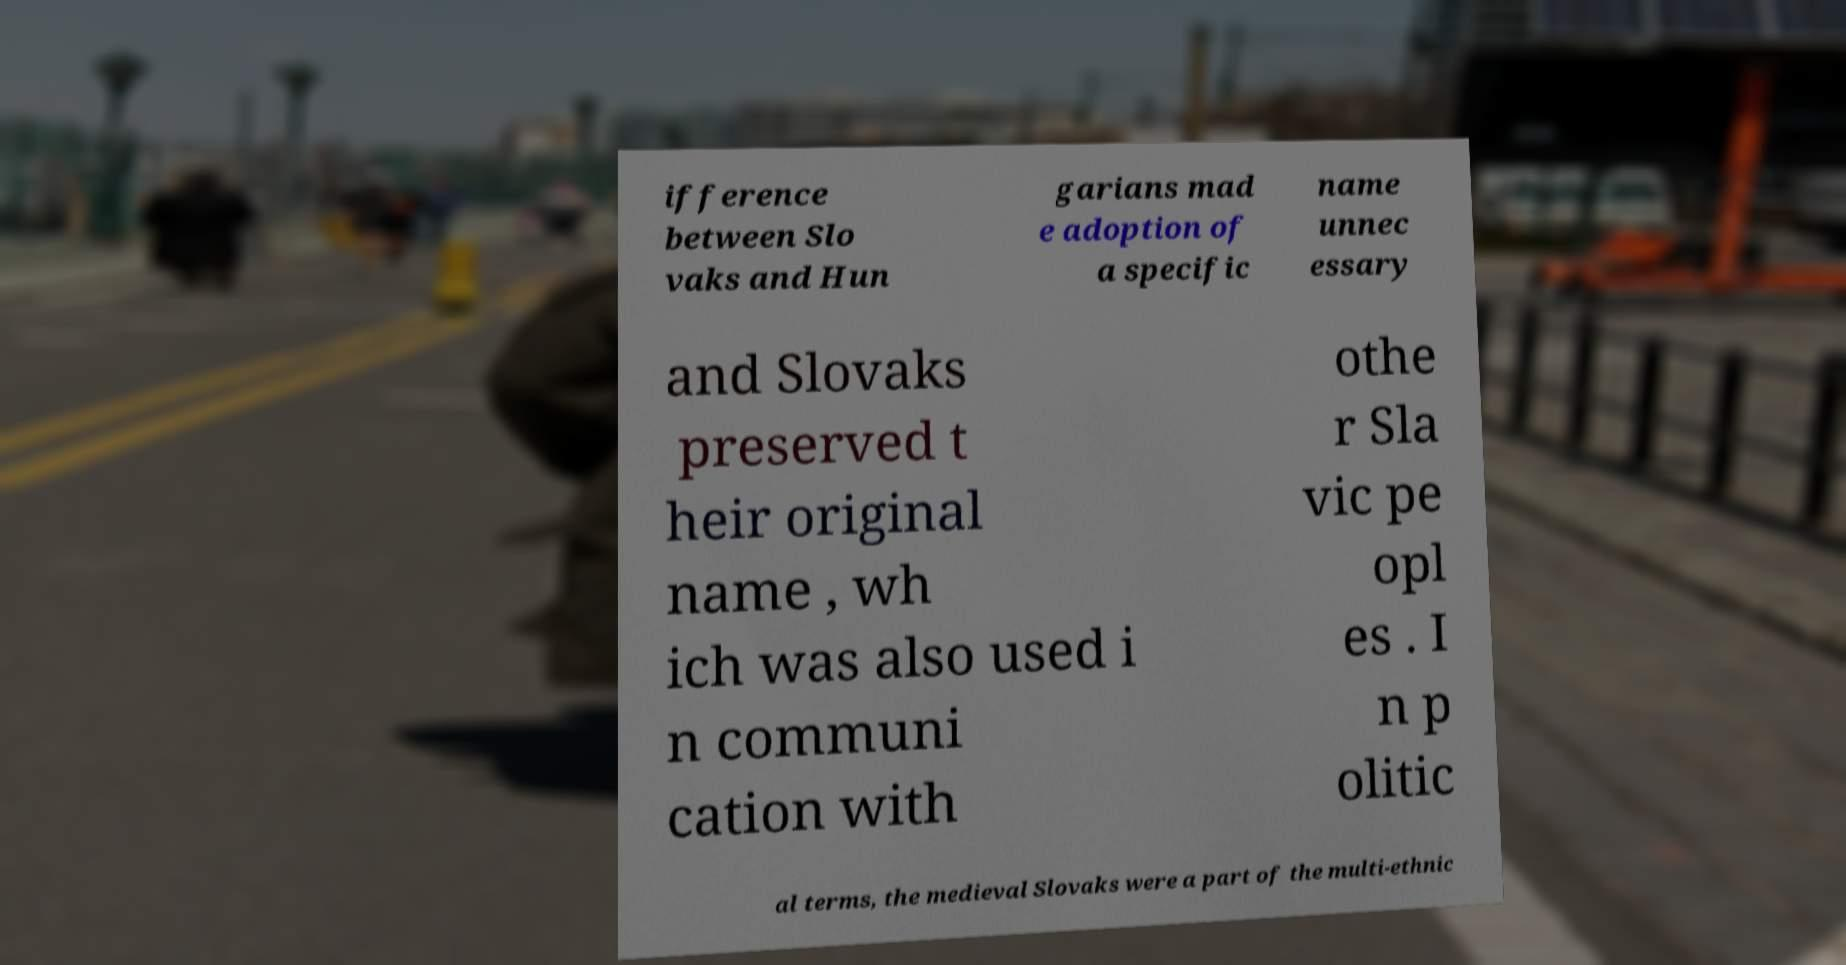Could you assist in decoding the text presented in this image and type it out clearly? ifference between Slo vaks and Hun garians mad e adoption of a specific name unnec essary and Slovaks preserved t heir original name , wh ich was also used i n communi cation with othe r Sla vic pe opl es . I n p olitic al terms, the medieval Slovaks were a part of the multi-ethnic 